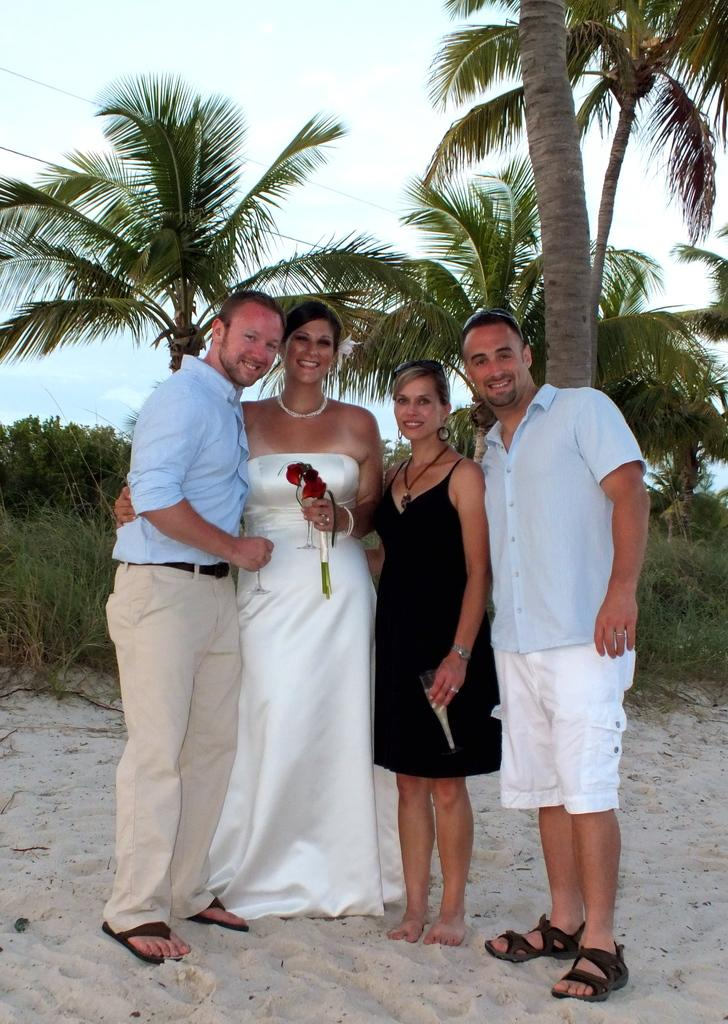What are the people in the image doing? The people in the image are standing and smiling. Can you describe what one of the people is holding? Yes, a person is holding flowers. What type of terrain is visible in the image? There is sand visible in the image. What can be seen in the background of the image? In the background of the image, there are trees, grass, plants, and the sky. What type of doll is sitting on the sand in the image? There is no doll present in the image; it features people standing and smiling, with a person holding flowers. 